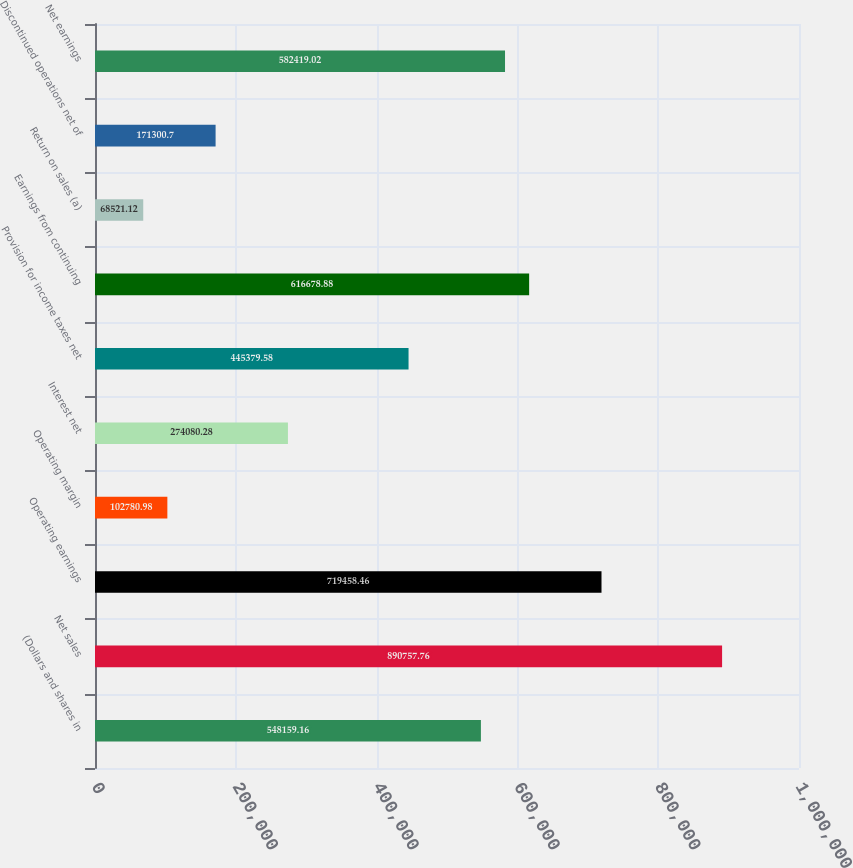Convert chart to OTSL. <chart><loc_0><loc_0><loc_500><loc_500><bar_chart><fcel>(Dollars and shares in<fcel>Net sales<fcel>Operating earnings<fcel>Operating margin<fcel>Interest net<fcel>Provision for income taxes net<fcel>Earnings from continuing<fcel>Return on sales (a)<fcel>Discontinued operations net of<fcel>Net earnings<nl><fcel>548159<fcel>890758<fcel>719458<fcel>102781<fcel>274080<fcel>445380<fcel>616679<fcel>68521.1<fcel>171301<fcel>582419<nl></chart> 